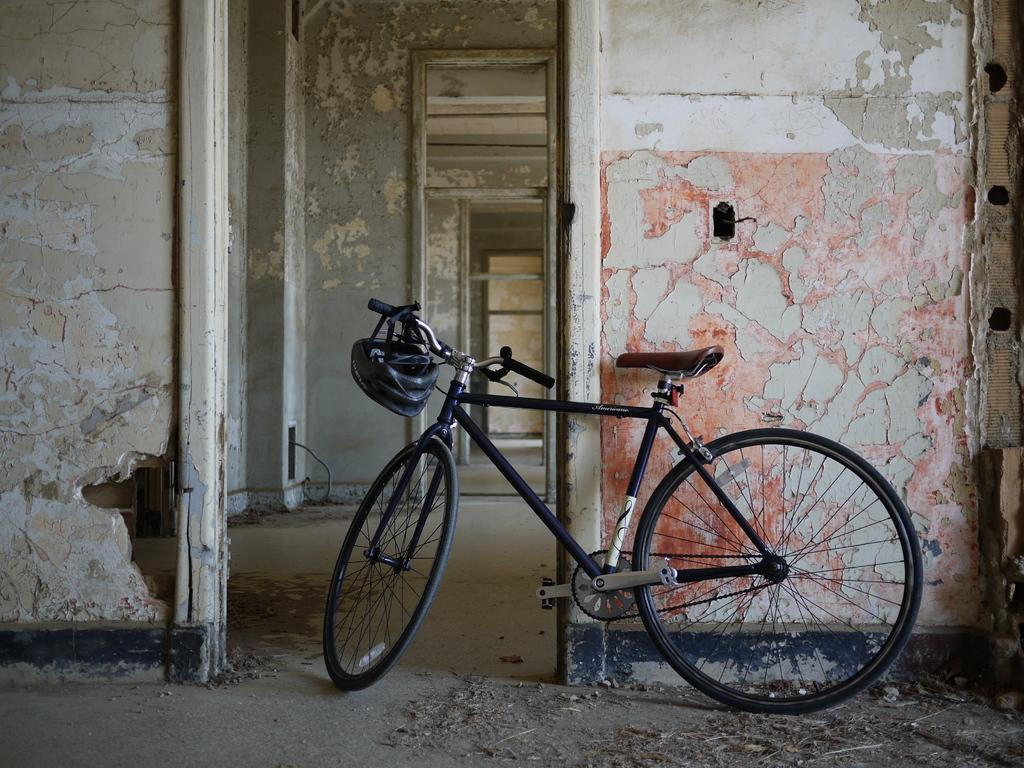What is the main object in the image? There is a bicycle in the image. What is located beside the bicycle? There is a wall with an entrance beside the bicycle. What can be seen in the background of the image? There are walls with entrances in the background of the image. What type of doctor is standing near the bicycle in the image? There is no doctor present in the image; it only features a bicycle and walls with entrances. 